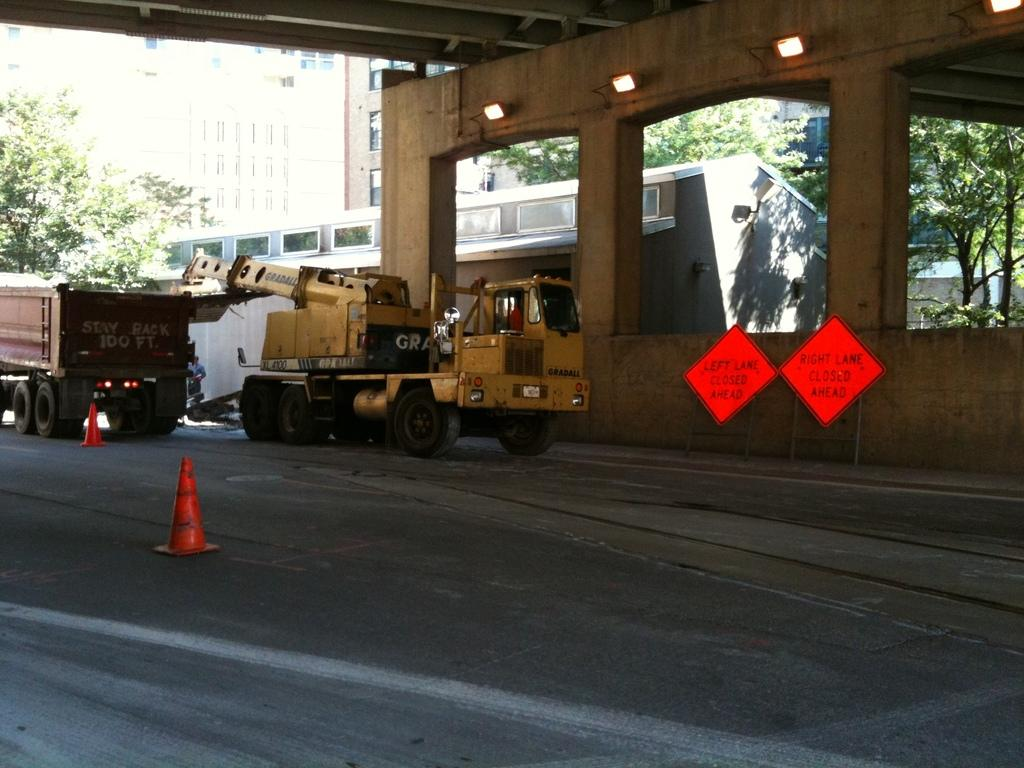Who or what is present in the image? There is a person in the image. What else can be seen in the image besides the person? There are two vehicles, two traffic cones, buildings, lights, and trees in the image. Can you describe the vehicles in the image? There are no specific details about the vehicles provided, but they are present in the image. What type of lights are visible in the image? There are no specific details about the lights provided, but they are present in the image. How does the worm contribute to the quiet atmosphere in the image? There is no worm present in the image, so it cannot contribute to the atmosphere or any other aspect of the image. 